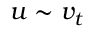Convert formula to latex. <formula><loc_0><loc_0><loc_500><loc_500>u \sim v _ { t }</formula> 